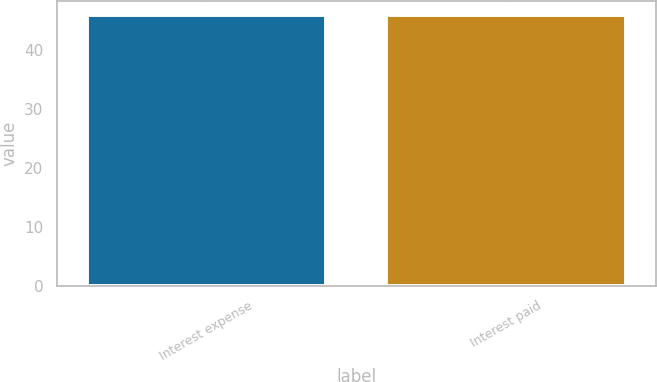<chart> <loc_0><loc_0><loc_500><loc_500><bar_chart><fcel>Interest expense<fcel>Interest paid<nl><fcel>46<fcel>46.1<nl></chart> 